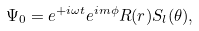Convert formula to latex. <formula><loc_0><loc_0><loc_500><loc_500>\Psi _ { 0 } = e ^ { + i \omega t } e ^ { i m \phi } R ( r ) S _ { l } ( \theta ) ,</formula> 